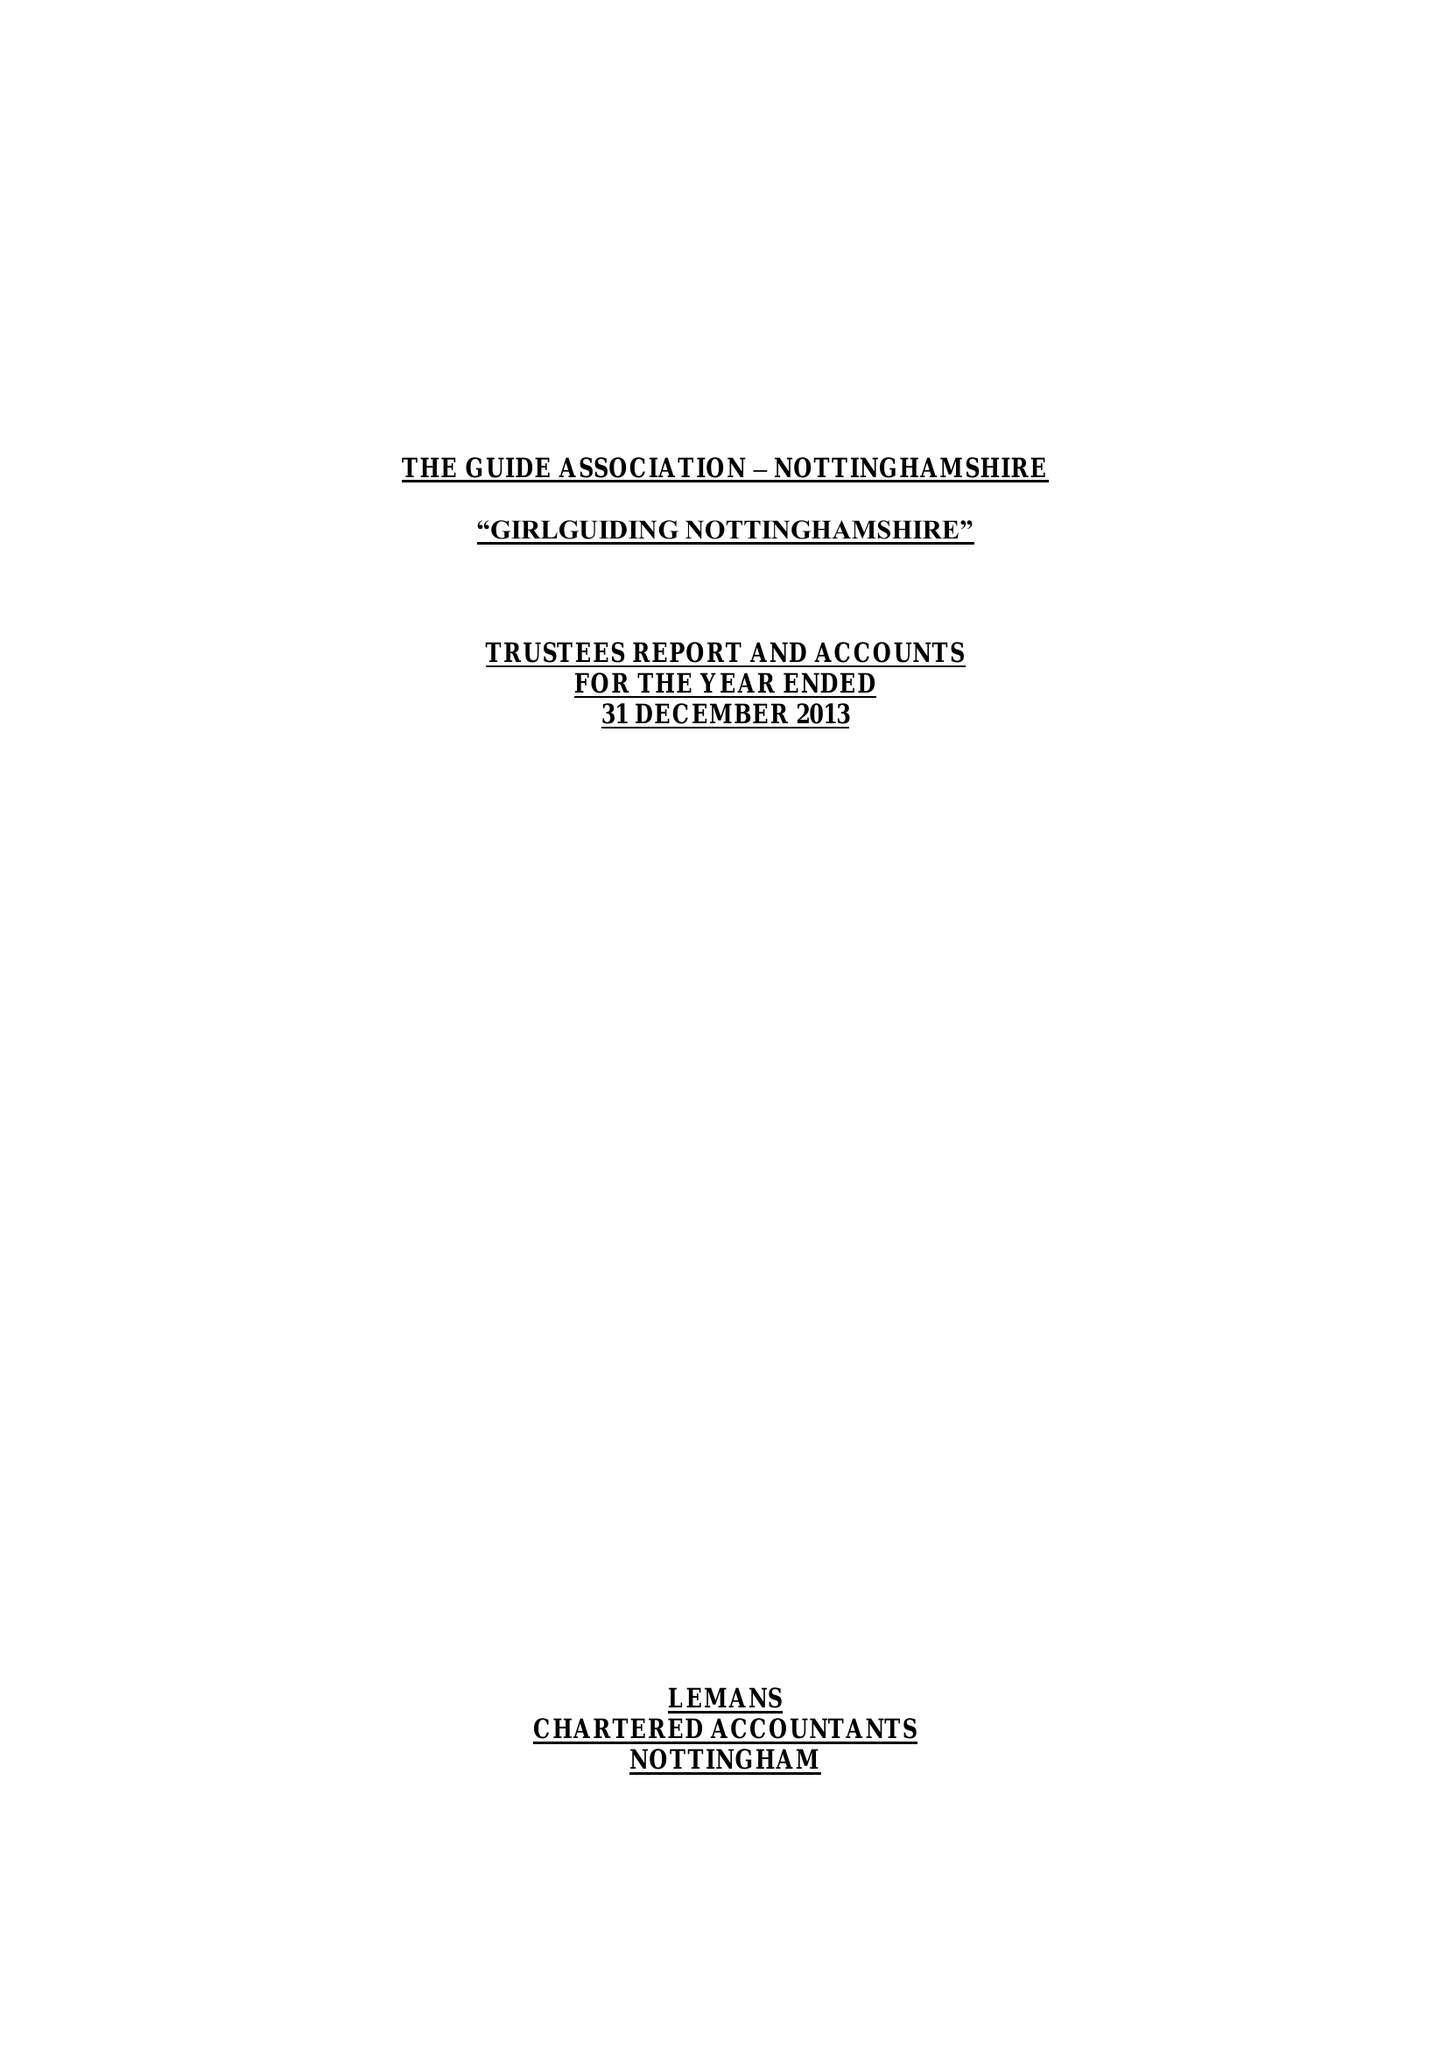What is the value for the spending_annually_in_british_pounds?
Answer the question using a single word or phrase. 207414.00 